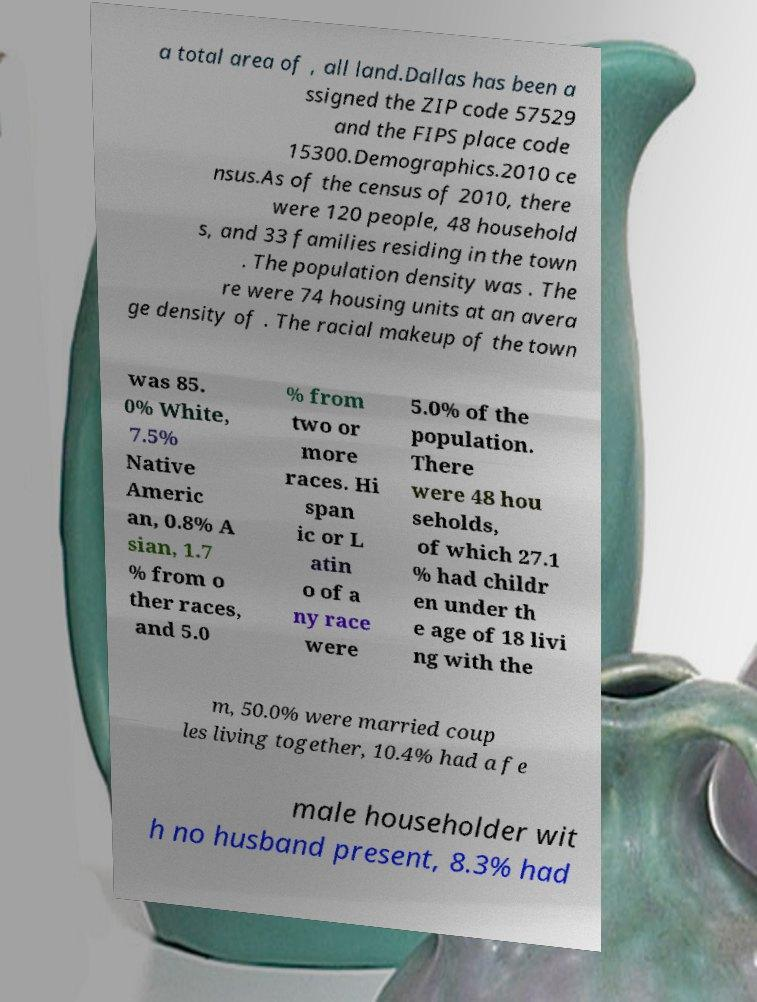For documentation purposes, I need the text within this image transcribed. Could you provide that? a total area of , all land.Dallas has been a ssigned the ZIP code 57529 and the FIPS place code 15300.Demographics.2010 ce nsus.As of the census of 2010, there were 120 people, 48 household s, and 33 families residing in the town . The population density was . The re were 74 housing units at an avera ge density of . The racial makeup of the town was 85. 0% White, 7.5% Native Americ an, 0.8% A sian, 1.7 % from o ther races, and 5.0 % from two or more races. Hi span ic or L atin o of a ny race were 5.0% of the population. There were 48 hou seholds, of which 27.1 % had childr en under th e age of 18 livi ng with the m, 50.0% were married coup les living together, 10.4% had a fe male householder wit h no husband present, 8.3% had 